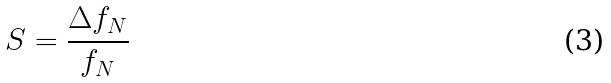<formula> <loc_0><loc_0><loc_500><loc_500>S = \frac { \Delta f _ { N } } { f _ { N } }</formula> 